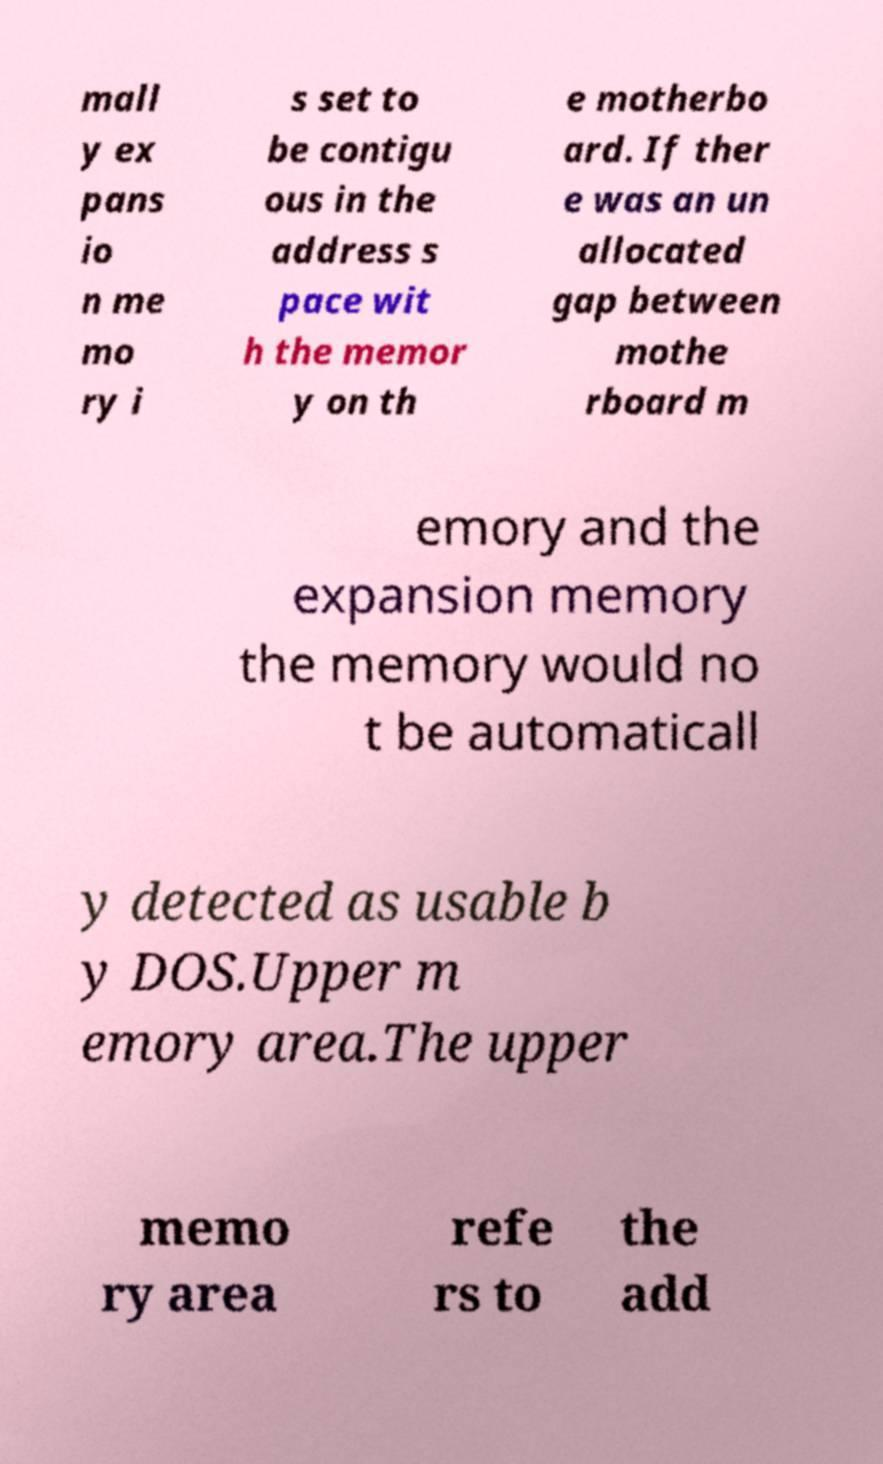Could you assist in decoding the text presented in this image and type it out clearly? mall y ex pans io n me mo ry i s set to be contigu ous in the address s pace wit h the memor y on th e motherbo ard. If ther e was an un allocated gap between mothe rboard m emory and the expansion memory the memory would no t be automaticall y detected as usable b y DOS.Upper m emory area.The upper memo ry area refe rs to the add 